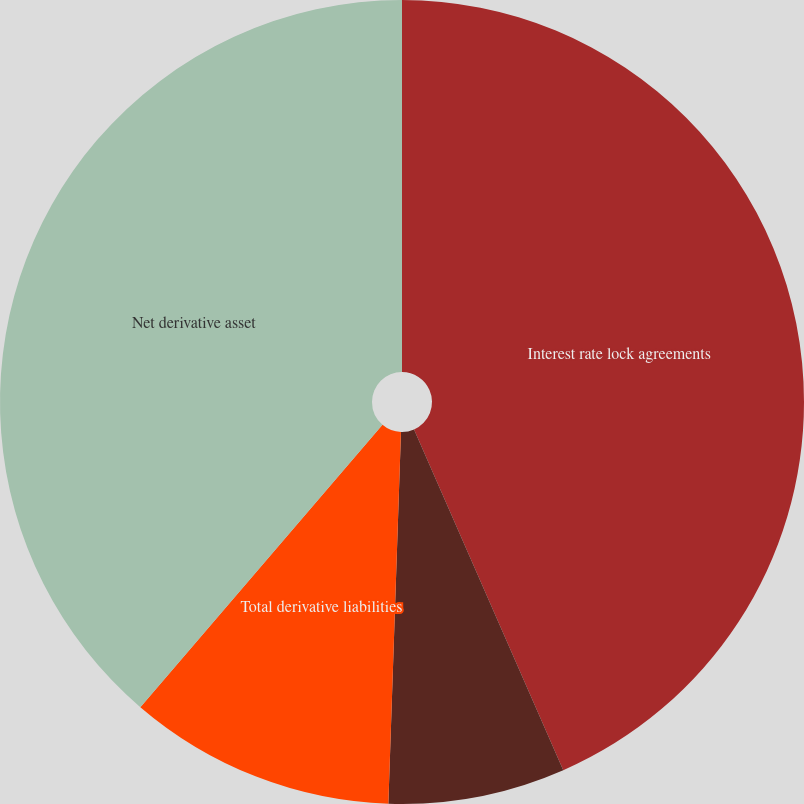Convert chart. <chart><loc_0><loc_0><loc_500><loc_500><pie_chart><fcel>Interest rate lock agreements<fcel>Forward trades and options<fcel>Total derivative liabilities<fcel>Net derivative asset<nl><fcel>43.43%<fcel>7.11%<fcel>10.74%<fcel>38.72%<nl></chart> 